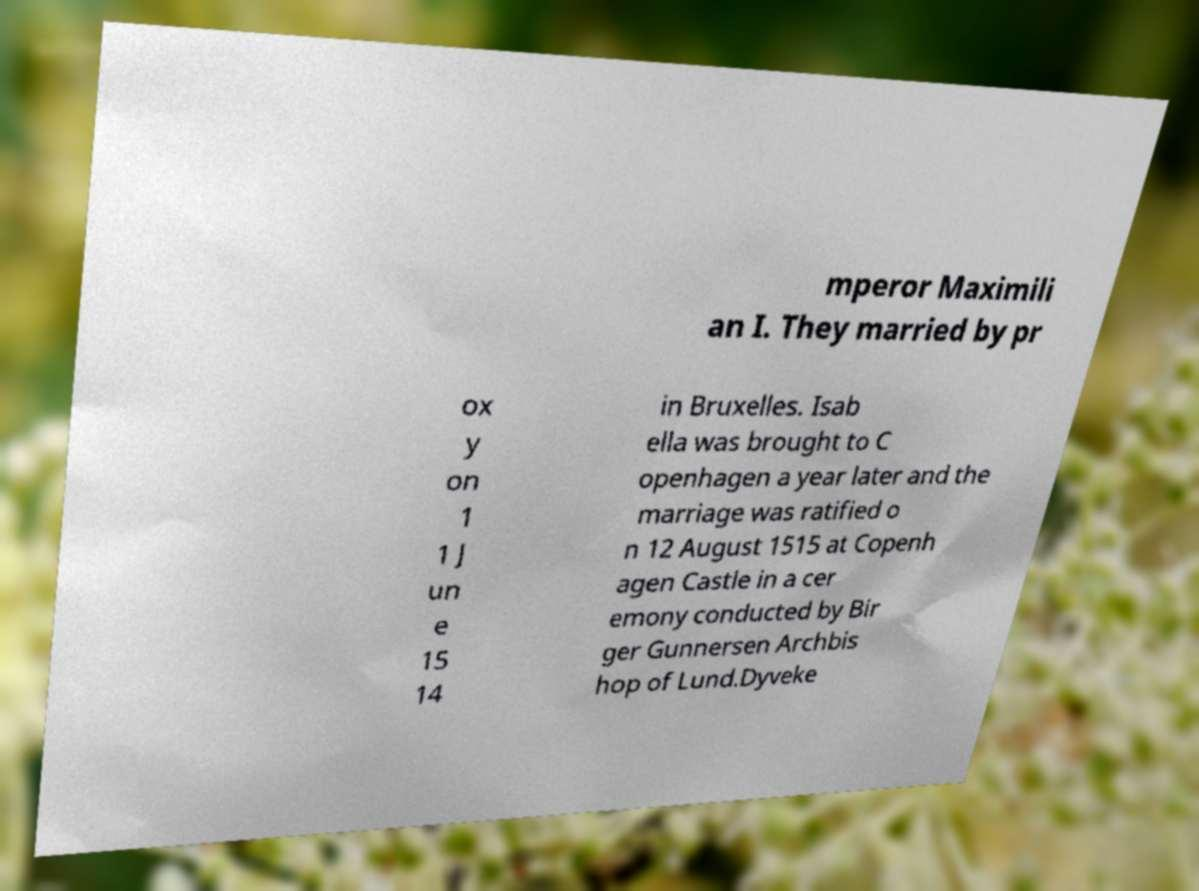Can you accurately transcribe the text from the provided image for me? mperor Maximili an I. They married by pr ox y on 1 1 J un e 15 14 in Bruxelles. Isab ella was brought to C openhagen a year later and the marriage was ratified o n 12 August 1515 at Copenh agen Castle in a cer emony conducted by Bir ger Gunnersen Archbis hop of Lund.Dyveke 